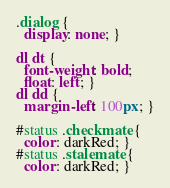Convert code to text. <code><loc_0><loc_0><loc_500><loc_500><_CSS_>.dialog {
  display: none; }

dl dt {
  font-weight: bold;
  float: left; }
dl dd {
  margin-left: 100px; }

#status .checkmate {
  color: darkRed; }
#status .stalemate {
  color: darkRed; }
</code> 